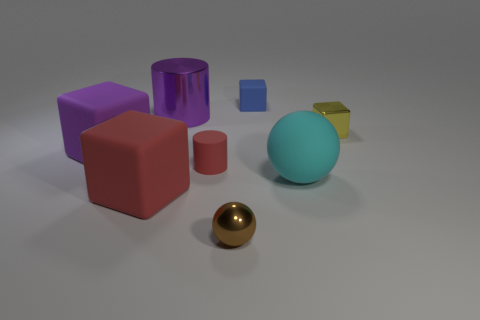Add 1 purple cubes. How many objects exist? 9 Subtract all rubber cubes. How many cubes are left? 1 Subtract all cyan spheres. How many spheres are left? 1 Subtract 1 blocks. How many blocks are left? 3 Add 8 gray metallic blocks. How many gray metallic blocks exist? 8 Subtract 0 blue cylinders. How many objects are left? 8 Subtract all cylinders. How many objects are left? 6 Subtract all purple cylinders. Subtract all gray cubes. How many cylinders are left? 1 Subtract all purple objects. Subtract all small yellow metal things. How many objects are left? 5 Add 6 rubber balls. How many rubber balls are left? 7 